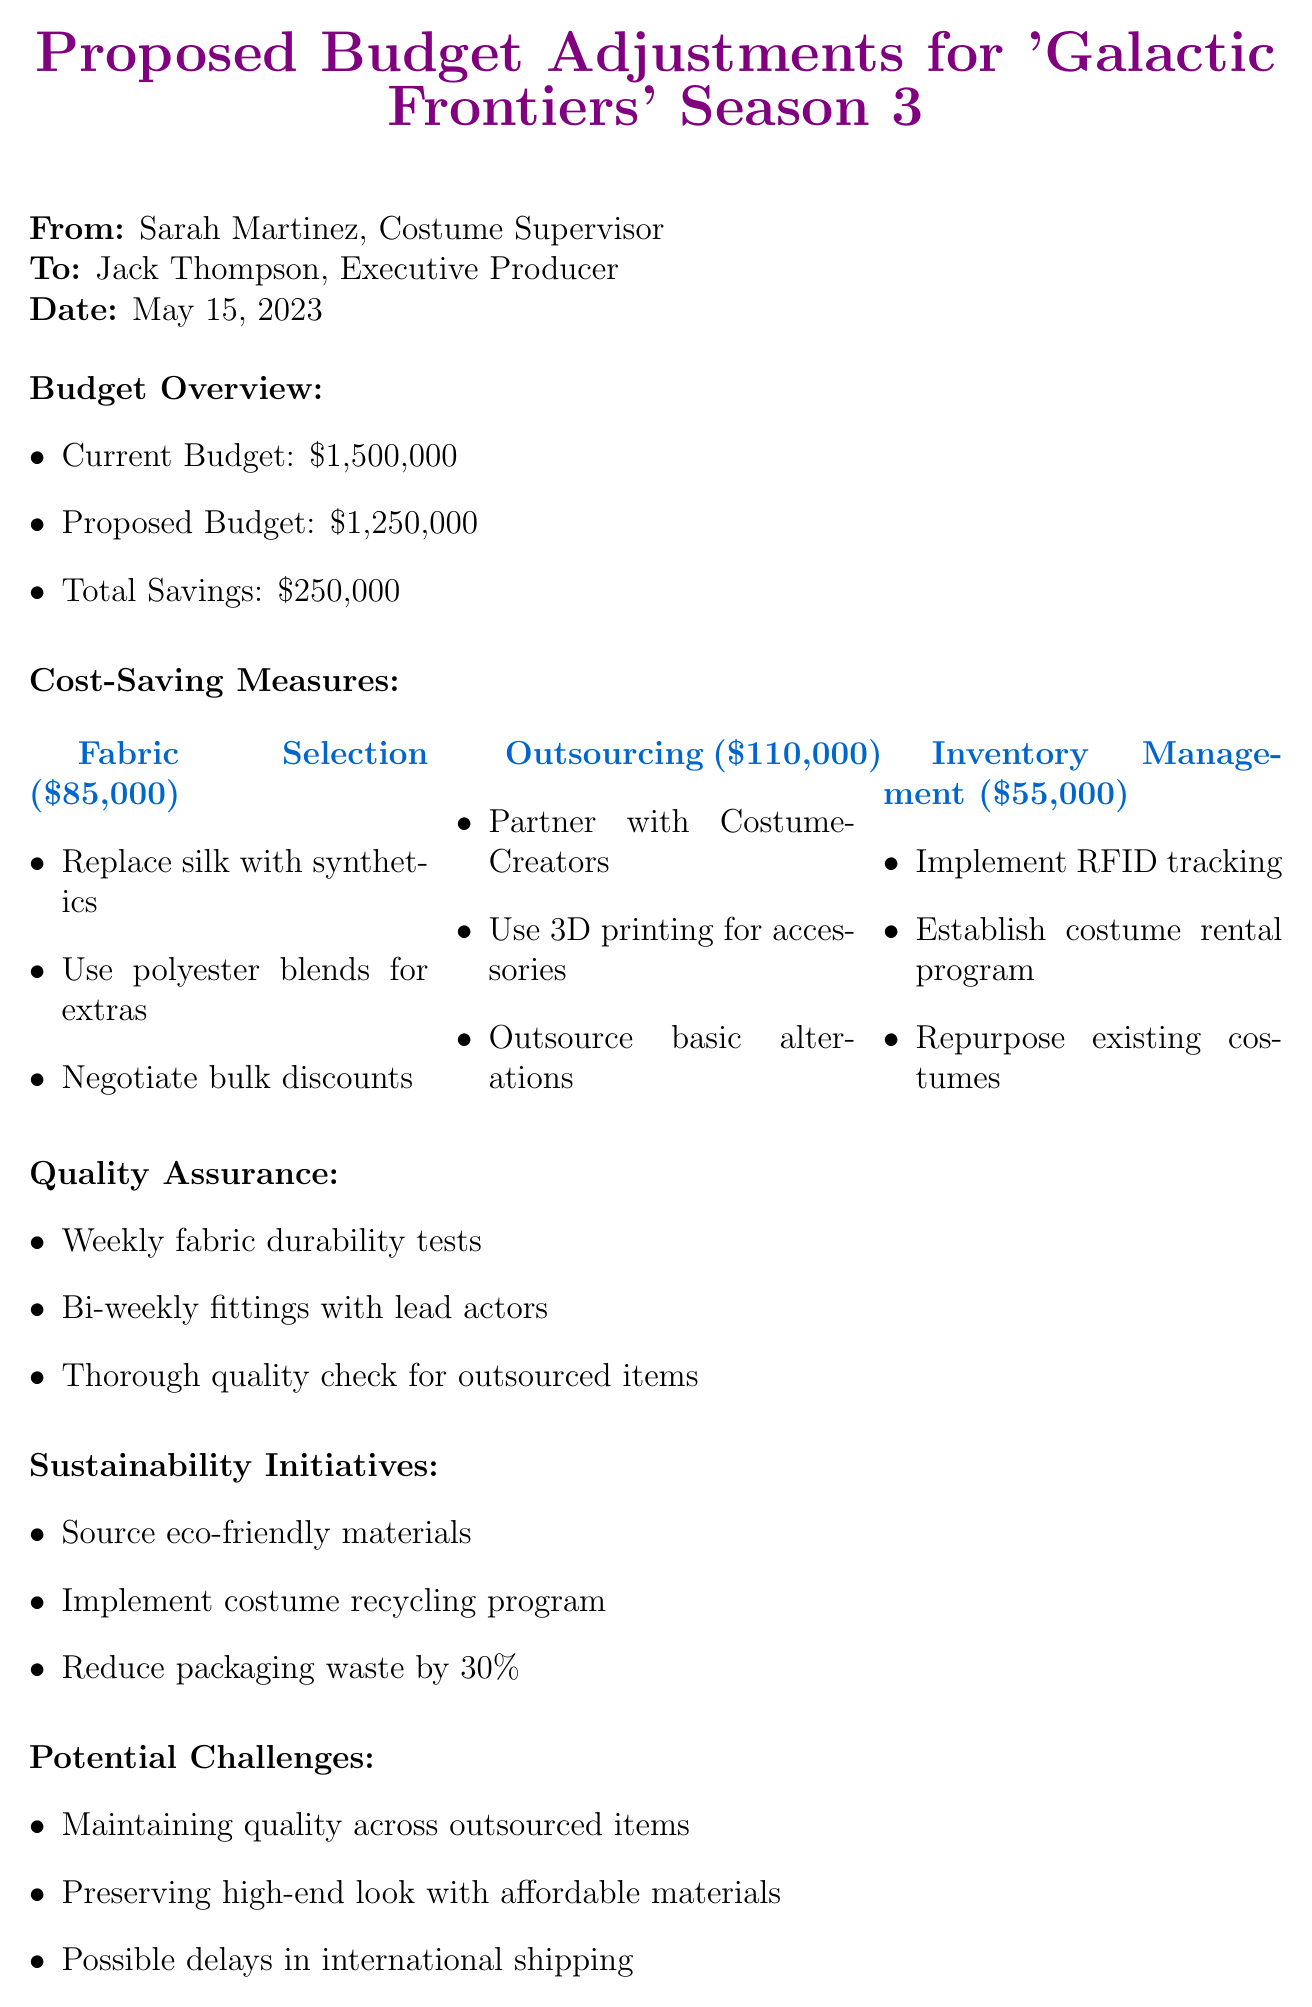What is the current budget? The current budget is explicitly stated in the budget overview section of the document.
Answer: $1,500,000 What is the proposed savings amount? This figure is the difference between the current budget and the proposed budget found in the budget overview.
Answer: $250,000 What company is suggested for synthetic fabric alternatives? This information can be found in the fabric selection cost-saving measures section.
Answer: Textile Innovations Inc How much is estimated to be saved from outsourcing? This figure is directly mentioned in the outsourcing cost-saving measures section.
Answer: $110,000 What quality assurance measure involves fabric tests? This measure is listed under the quality assurance measures section of the memo.
Answer: Weekly fabric durability tests What is the conclusion about the proposed measures? The conclusion summarizes the expected outcome of the proposed budget adjustments detailed in the document.
Answer: Reduce budget while maintaining high-quality standards What potential challenge is related to outsourced items? This challenge is detailed under the potential challenges section of the memo.
Answer: Maintaining quality across outsourced items Which sustainability initiative aims at reducing waste? This initiative is directly mentioned in the sustainability initiatives section of the document.
Answer: Reduce packaging waste by 30% What percentage of savings does fabric selection contribute? This percentage is detailed in the cost-saving measures section along with its corresponding savings amount.
Answer: $85,000 